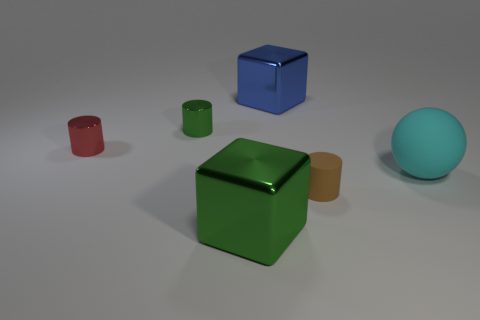Subtract all metallic cylinders. How many cylinders are left? 1 Add 2 tiny green cylinders. How many objects exist? 8 Subtract all balls. How many objects are left? 5 Add 4 tiny green cylinders. How many tiny green cylinders are left? 5 Add 1 green metal cubes. How many green metal cubes exist? 2 Subtract 0 cyan cubes. How many objects are left? 6 Subtract all small things. Subtract all tiny gray matte blocks. How many objects are left? 3 